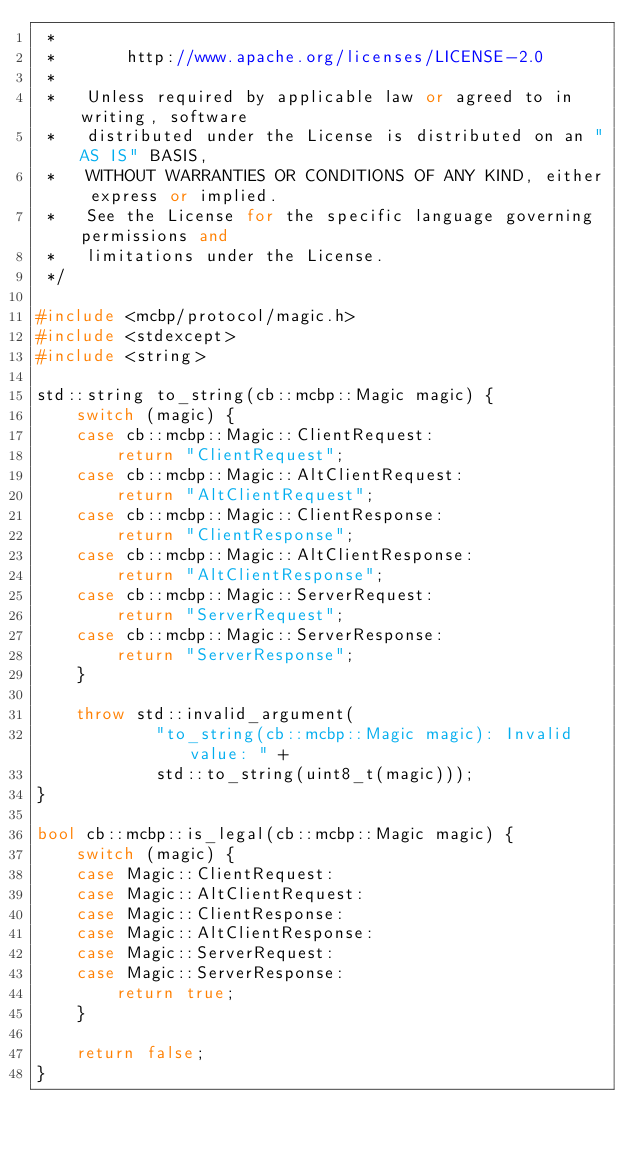<code> <loc_0><loc_0><loc_500><loc_500><_C++_> *
 *       http://www.apache.org/licenses/LICENSE-2.0
 *
 *   Unless required by applicable law or agreed to in writing, software
 *   distributed under the License is distributed on an "AS IS" BASIS,
 *   WITHOUT WARRANTIES OR CONDITIONS OF ANY KIND, either express or implied.
 *   See the License for the specific language governing permissions and
 *   limitations under the License.
 */

#include <mcbp/protocol/magic.h>
#include <stdexcept>
#include <string>

std::string to_string(cb::mcbp::Magic magic) {
    switch (magic) {
    case cb::mcbp::Magic::ClientRequest:
        return "ClientRequest";
    case cb::mcbp::Magic::AltClientRequest:
        return "AltClientRequest";
    case cb::mcbp::Magic::ClientResponse:
        return "ClientResponse";
    case cb::mcbp::Magic::AltClientResponse:
        return "AltClientResponse";
    case cb::mcbp::Magic::ServerRequest:
        return "ServerRequest";
    case cb::mcbp::Magic::ServerResponse:
        return "ServerResponse";
    }

    throw std::invalid_argument(
            "to_string(cb::mcbp::Magic magic): Invalid value: " +
            std::to_string(uint8_t(magic)));
}

bool cb::mcbp::is_legal(cb::mcbp::Magic magic) {
    switch (magic) {
    case Magic::ClientRequest:
    case Magic::AltClientRequest:
    case Magic::ClientResponse:
    case Magic::AltClientResponse:
    case Magic::ServerRequest:
    case Magic::ServerResponse:
        return true;
    }

    return false;
}
</code> 